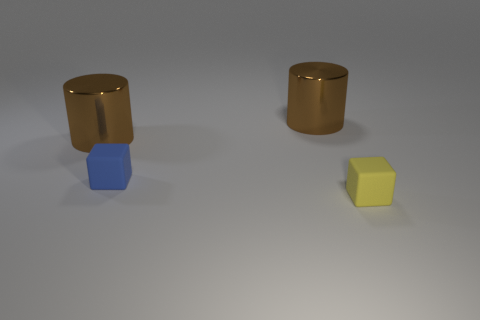What number of other shiny things have the same size as the blue object?
Offer a very short reply. 0. There is a big thing that is to the left of the blue block that is to the left of the yellow object; what number of objects are in front of it?
Your response must be concise. 2. Are there an equal number of blue things that are right of the small yellow matte cube and blue blocks in front of the blue block?
Your response must be concise. Yes. What number of tiny blue objects have the same shape as the tiny yellow thing?
Your response must be concise. 1. Is there a tiny blue thing made of the same material as the small yellow block?
Offer a terse response. Yes. What number of brown metal things are there?
Give a very brief answer. 2. How many cylinders are either yellow matte things or shiny things?
Offer a terse response. 2. The object that is the same size as the yellow rubber cube is what color?
Ensure brevity in your answer.  Blue. How many objects are to the right of the small blue cube and behind the blue object?
Make the answer very short. 1. What is the material of the yellow thing?
Keep it short and to the point. Rubber. 